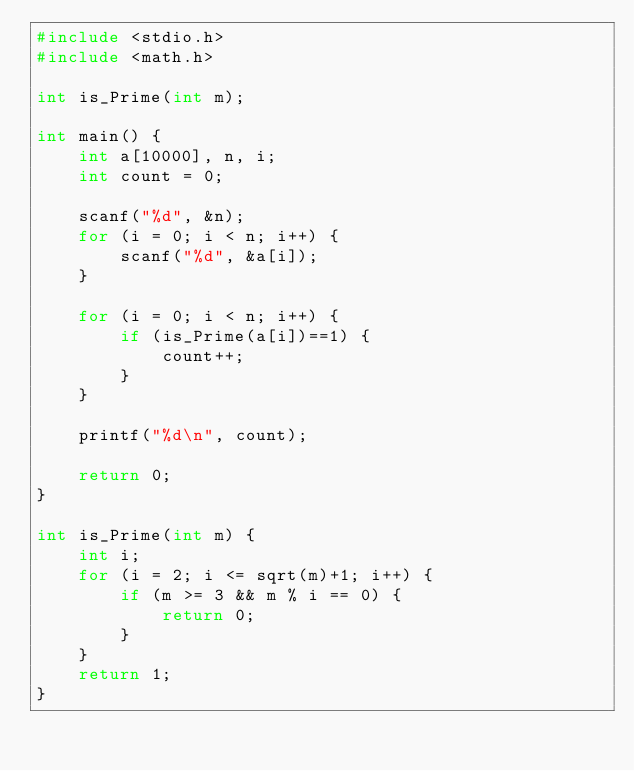Convert code to text. <code><loc_0><loc_0><loc_500><loc_500><_C_>#include <stdio.h>
#include <math.h>

int is_Prime(int m);

int main() {
	int a[10000], n, i;
	int count = 0;

	scanf("%d", &n);
	for (i = 0; i < n; i++) {
		scanf("%d", &a[i]);
	}
	
	for (i = 0; i < n; i++) {
		if (is_Prime(a[i])==1) {
			count++;
		}
	}

	printf("%d\n", count);

	return 0;
}

int is_Prime(int m) {
	int i;
	for (i = 2; i <= sqrt(m)+1; i++) {
		if (m >= 3 && m % i == 0) {
			return 0;
		}
	}
	return 1;
}</code> 